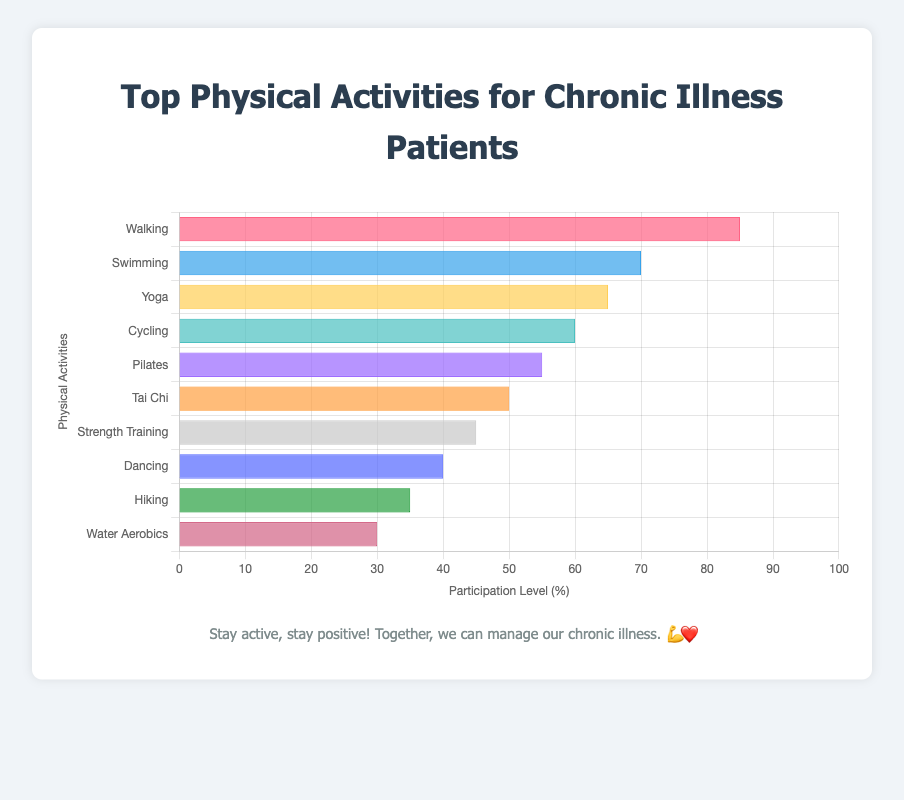Which physical activity has the highest participation level? The chart shows a list of physical activities with their respective participation levels. By comparing the heights of the bars, we can see that "Walking" has the highest participation level at 85%.
Answer: Walking What is the difference in participation levels between Swimming and Strength Training? Looking at the bar for Swimming (70%) and the bar for Strength Training (45%), the difference in participation levels is calculated as 70% - 45% = 25%.
Answer: 25% Which activity has a lower participation level: Dancing or Water Aerobics? By comparing the heights of the bars, we see that Water Aerobics has a participation level of 30% and Dancing has a level of 40%. Therefore, Water Aerobics has the lower participation level.
Answer: Water Aerobics What is the total participation level for Yoga and Pilates combined? The chart shows participation levels of 65% for Yoga and 55% for Pilates. Adding these two values, we get 65% + 55% = 120%.
Answer: 120% Among Tai Chi, Strength Training, and Hiking, which activity has the highest participation level? By comparing the heights of the bars, Tai Chi has a participation level of 50%, Strength Training has 45%, and Hiking has 35%. Therefore, Tai Chi has the highest participation level among them.
Answer: Tai Chi Which physical activities have participation levels greater than 50%? Observing the chart, the activities with participation levels greater than 50% are Walking (85%), Swimming (70%), Yoga (65%), Cycling (60%), and Pilates (55%).
Answer: Walking, Swimming, Yoga, Cycling, Pilates If we average the participation levels of the top three activities, what do we get? The top three activities by participation levels are Walking (85%), Swimming (70%), and Yoga (65%). The average is calculated as (85% + 70% + 65%) / 3 = 220% / 3 ≈ 73.33%.
Answer: 73.33% Is Tai Chi more popular than Cycling in terms of participation levels? The chart shows that Tai Chi has a participation level of 50%, while Cycling has a level of 60%. Since 50% is less than 60%, Tai Chi is less popular than Cycling.
Answer: No How many activities have participation levels below 40%? Observing the chart, the activities with participation levels below 40% are Hiking (35%) and Water Aerobics (30%). Therefore, there are 2 activities with participation levels below 40%.
Answer: 2 